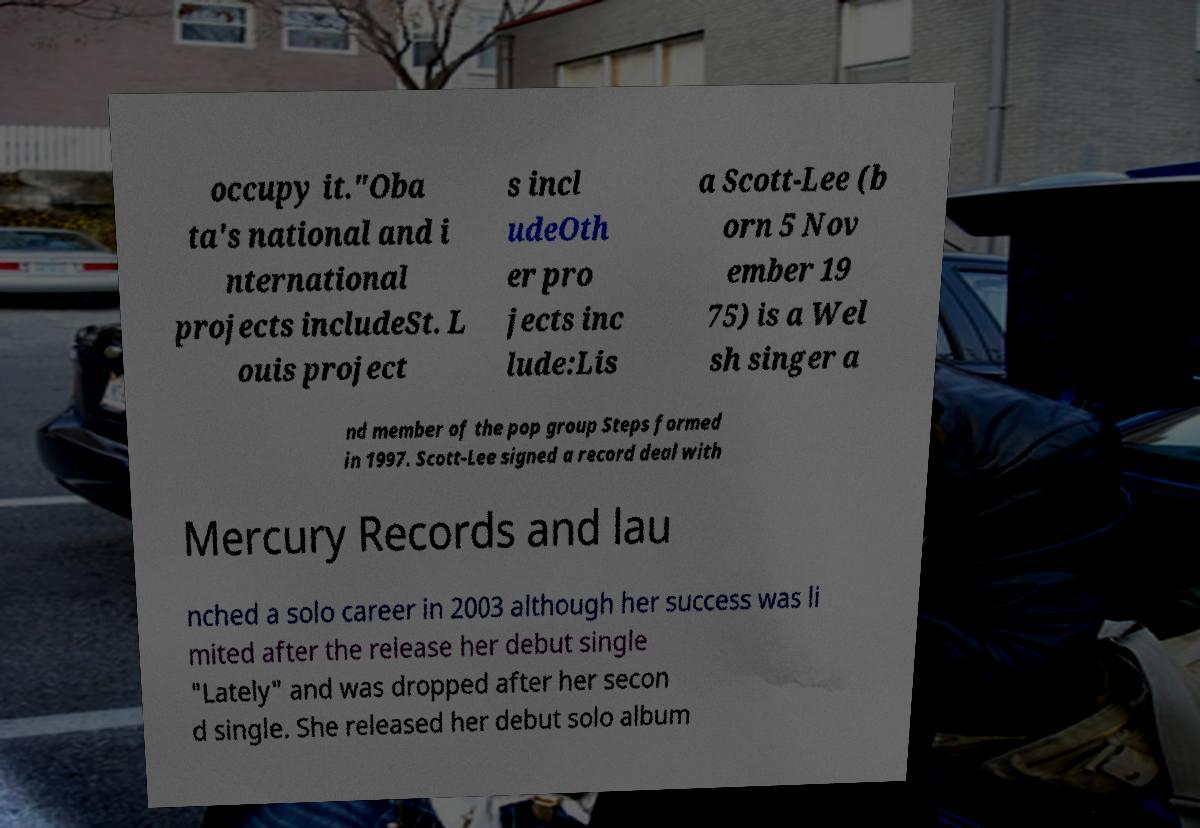For documentation purposes, I need the text within this image transcribed. Could you provide that? occupy it."Oba ta's national and i nternational projects includeSt. L ouis project s incl udeOth er pro jects inc lude:Lis a Scott-Lee (b orn 5 Nov ember 19 75) is a Wel sh singer a nd member of the pop group Steps formed in 1997. Scott-Lee signed a record deal with Mercury Records and lau nched a solo career in 2003 although her success was li mited after the release her debut single "Lately" and was dropped after her secon d single. She released her debut solo album 